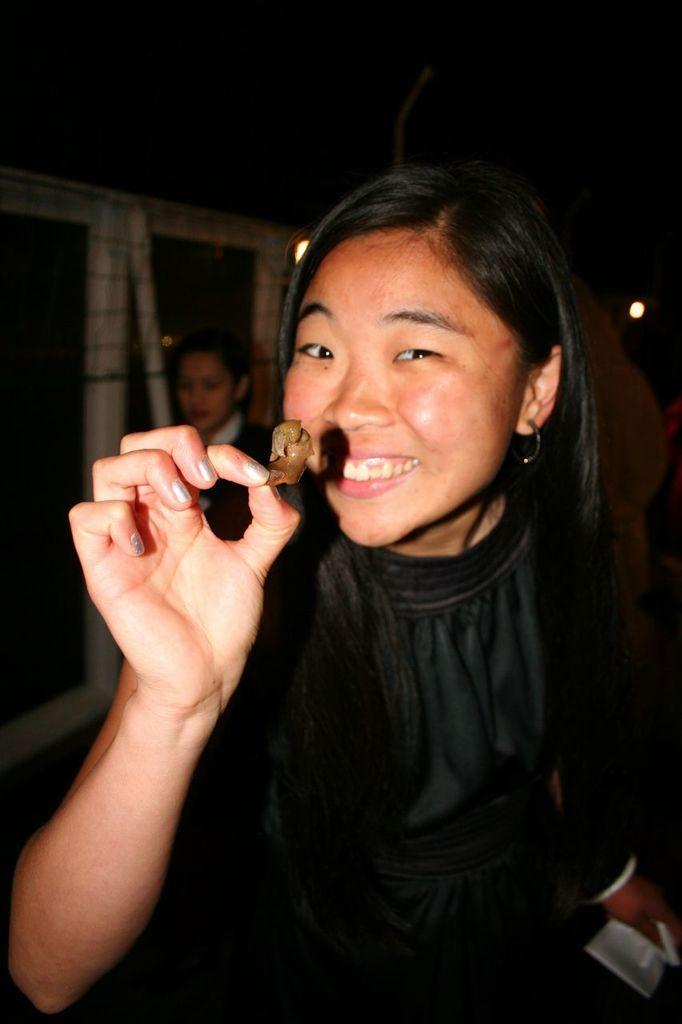Could you give a brief overview of what you see in this image? In this image we can see a woman holding some food. On the backside we can see a wall, windows and a woman standing. 